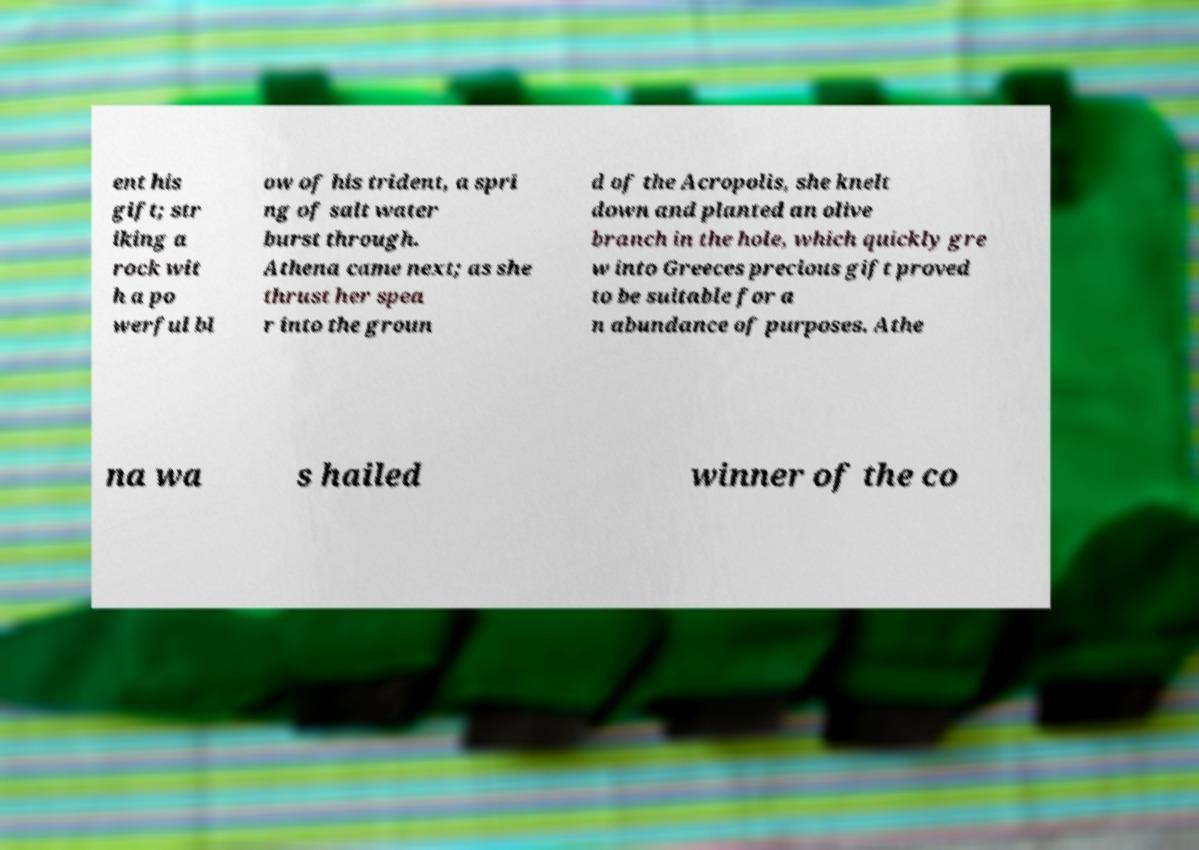Can you accurately transcribe the text from the provided image for me? ent his gift; str iking a rock wit h a po werful bl ow of his trident, a spri ng of salt water burst through. Athena came next; as she thrust her spea r into the groun d of the Acropolis, she knelt down and planted an olive branch in the hole, which quickly gre w into Greeces precious gift proved to be suitable for a n abundance of purposes. Athe na wa s hailed winner of the co 